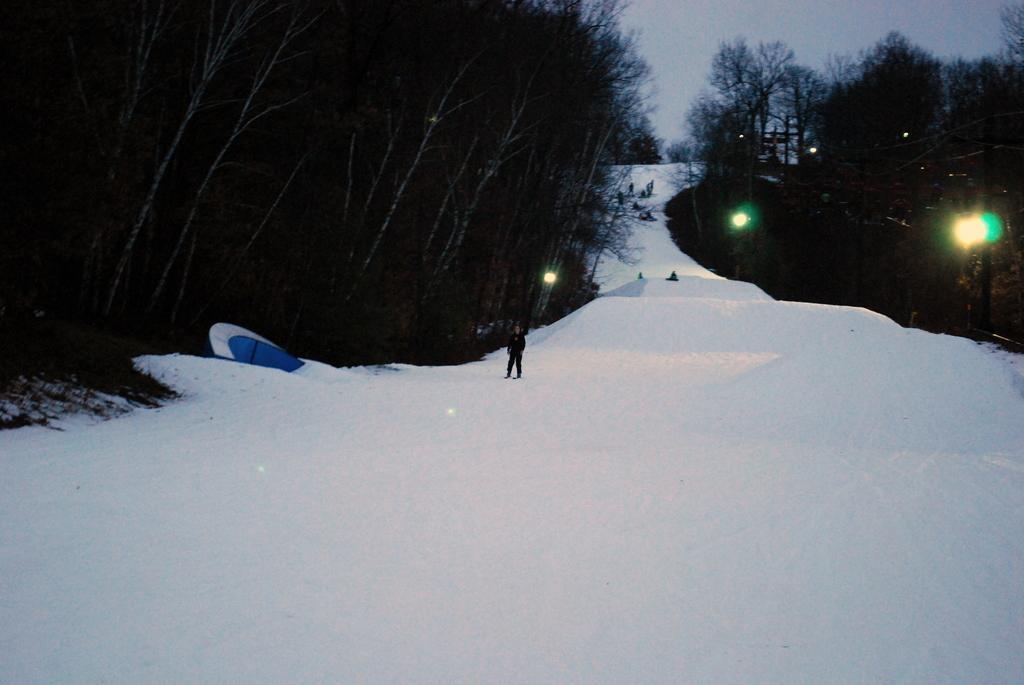How would you summarize this image in a sentence or two? In the center of the image there is snow. To the both sides of the image there are trees. At the top of the image there is sky. 